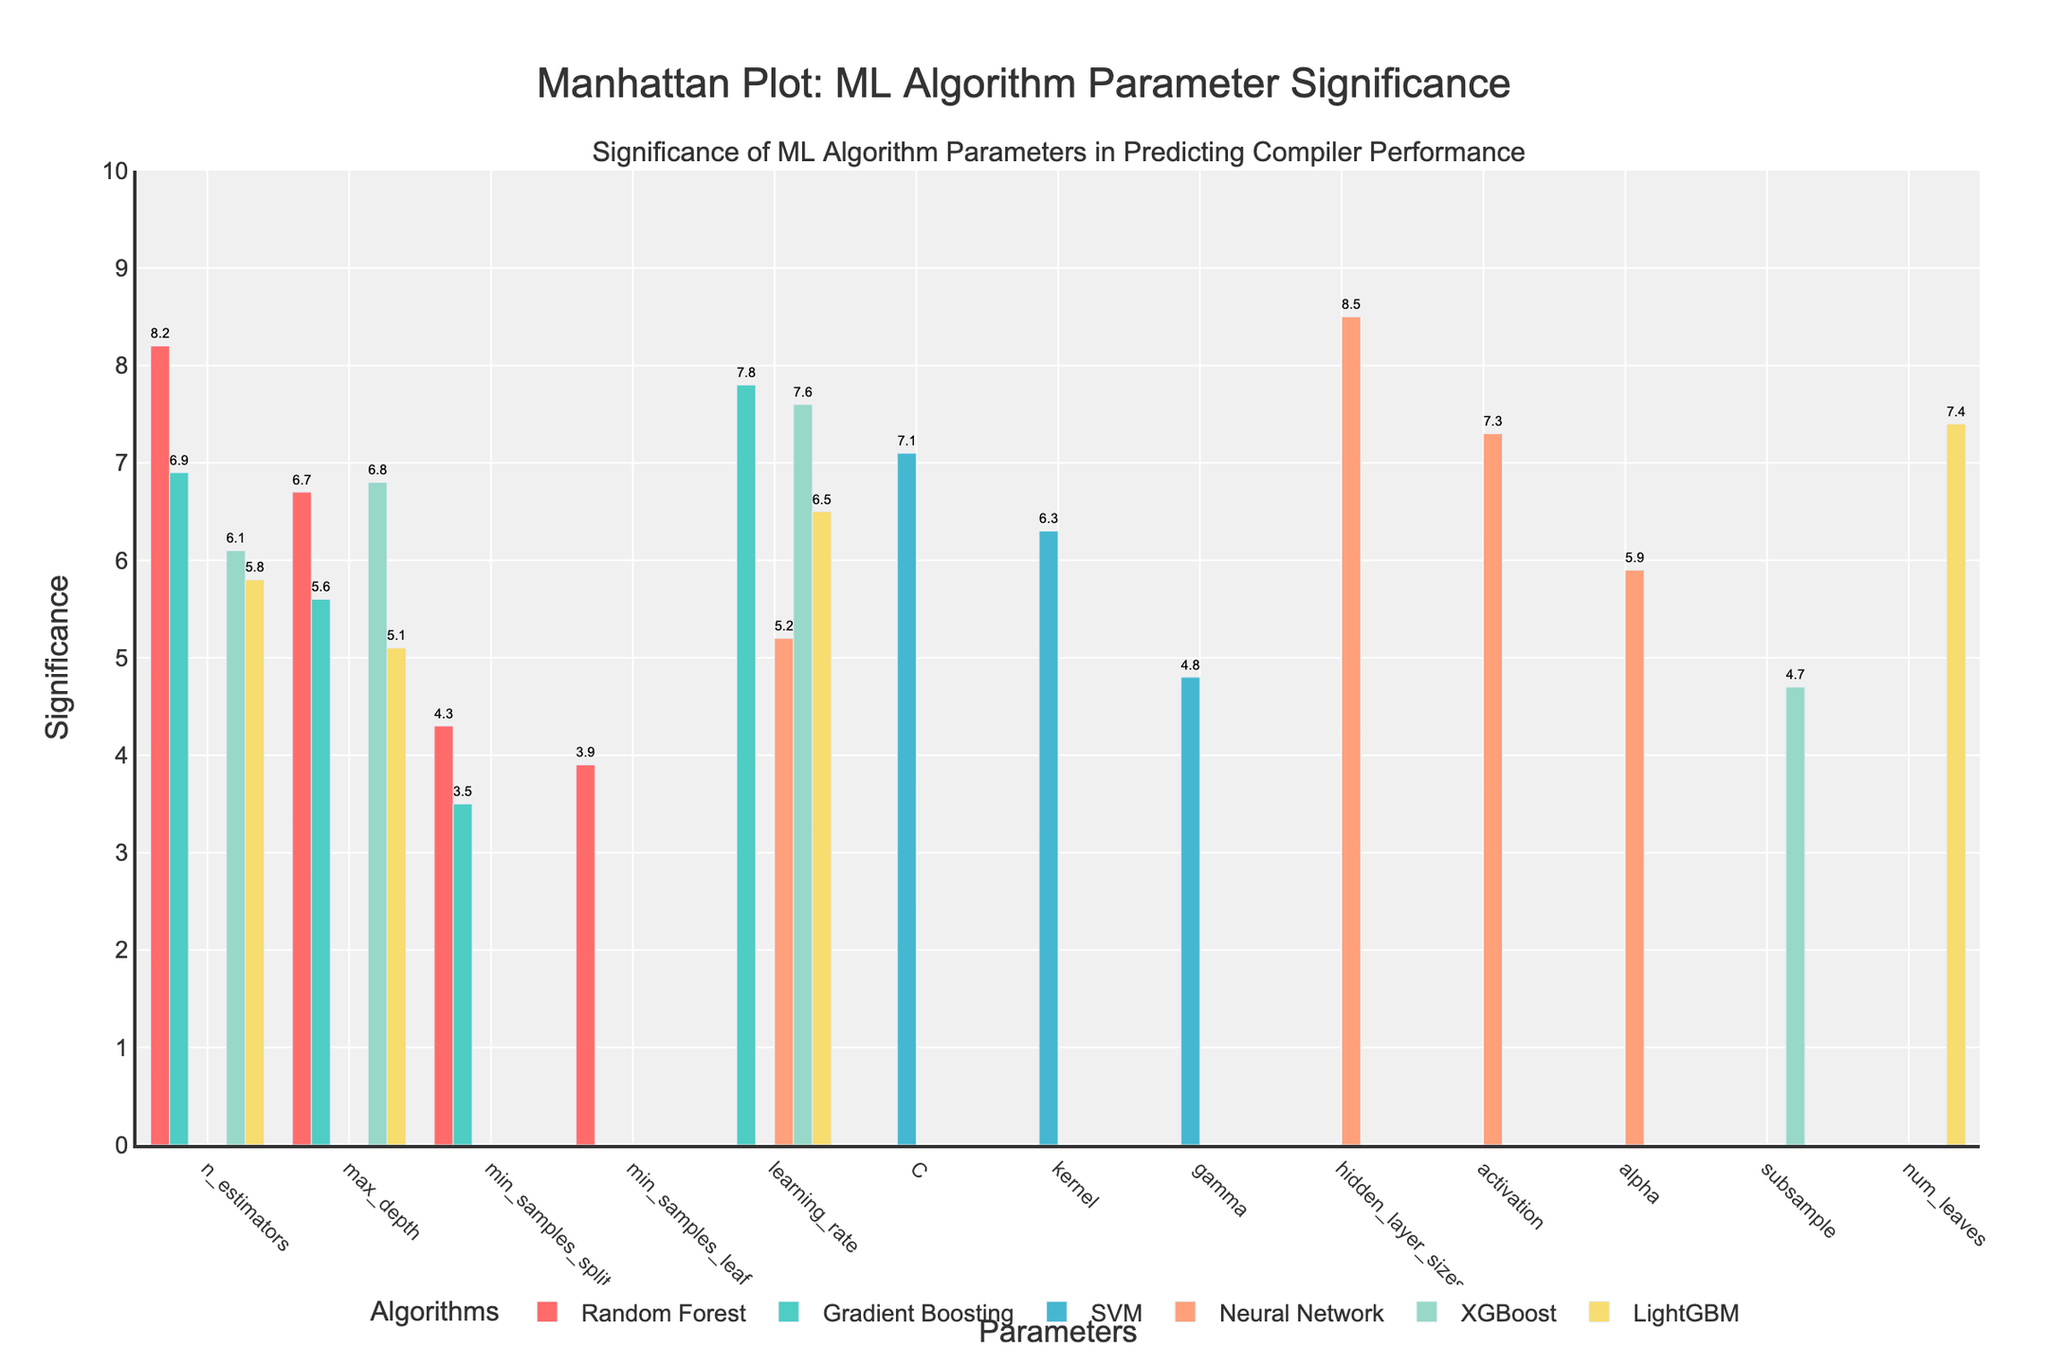What is the title of the plot? The title is usually at the top of the plot. In this case, it is "Manhattan Plot: ML Algorithm Parameter Significance".
Answer: Manhattan Plot: ML Algorithm Parameter Significance Which algorithm has the highest significant parameter? Look for the highest bar in the plot and identify the associated algorithm. Here, the highest bar represents the Neural Network with the parameter "hidden_layer_sizes" having a significance of 8.5.
Answer: Neural Network What is the significance value of the n_estimators parameter for the Random Forest algorithm? Locate the Random Forest category and find the bar representing the "n_estimators" parameter; the corresponding significance value is 8.2.
Answer: 8.2 Compare the significance values of the learning_rate parameter across different algorithms. What do you observe? Locate the bars for "learning_rate" in Gradient Boosting, Neural Network, XGBoost, and LightGBM. Gradient Boosting: 7.8, Neural Network: 5.2, XGBoost: 7.6, LightGBM: 6.5. The values vary but are generally around 5.2 to 7.8.
Answer: Varies, highest in Gradient Boosting (7.8) How many parameters have a significance value greater than 7? Count the bars with significance values greater than 7. These are Neural Network "hidden_layer_sizes" (8.5), Random Forest "n_estimators" (8.2), Gradient Boosting "learning_rate" (7.8), SVM "C" (7.1), LightGBM "num_leaves" (7.4), and XGBoost "learning_rate" (7.6).
Answer: 6 Which algorithm has the most parameters listed, and how many are there? Count the number of parameters for each algorithm. Random Forest, Gradient Boosting, XGBoost, and LightGBM each have 4 parameters. Neural Network has 4 as well. SVM has 3 parameters.
Answer: Random Forest, Gradient Boosting, XGBoost, LightGBM, and Neural Network (4 each) What is the significance value for the max_depth parameter in different algorithms, and which one has the highest? Compare the "max_depth" parameter significance values: Random Forest (6.7), Gradient Boosting (5.6), LightGBM (5.1), and XGBoost (6.8). The highest is 6.8 for XGBoost.
Answer: XGBoost (6.8) Identify the least significant parameter in the SVM algorithm. Look for the bar representing the SVM parameters with the lowest significance value, which is "gamma" with a significance of 4.8.
Answer: gamma (4.8) What is the difference in significance between the highest and lowest parameters in the Neural Network algorithm? The highest is "hidden_layer_sizes" at 8.5 and the lowest is "learning_rate" at 5.2. The difference is 8.5 - 5.2 = 3.3.
Answer: 3.3 Which parameter has the lowest overall significance and in which algorithm is it found? Find the smallest bar among all categories. The parameter "min_samples_leaf" in Random Forest has the lowest significance value of 3.9.
Answer: min_samples_leaf (Random Forest) 